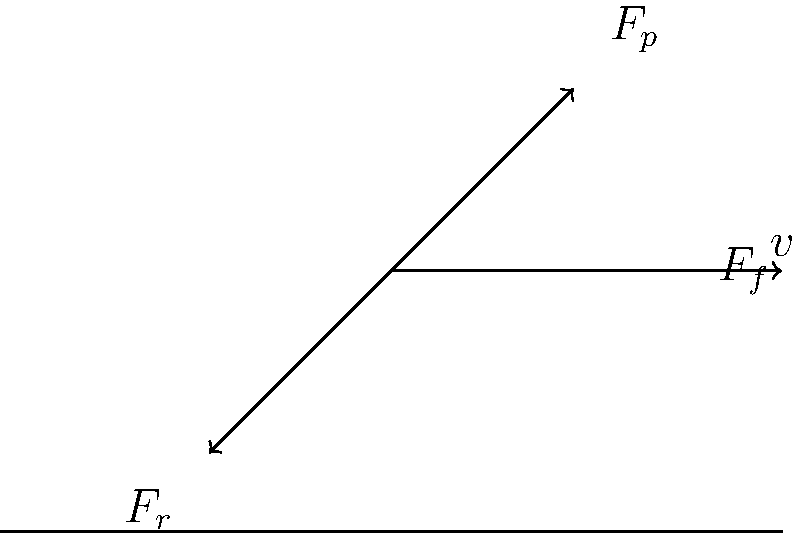While cycling through the bustling streets of Khulna, you apply a force $F_p$ on the pedal. If the wheel's radius is 0.3 m and you're maintaining a constant speed of 5 m/s, what is the magnitude of the resistive force $F_r$ acting on the wheel, assuming no energy loss in the system? To solve this problem, we'll follow these steps:

1) First, we need to understand that at constant speed, the net force on the system is zero. This means the propulsive force must equal the resistive force.

2) The propulsive force at the wheel rim ($F_f$) is related to the pedal force ($F_p$) through the gear ratio. However, we don't need to know this relationship for this problem.

3) The power input at the pedal equals the power output at the wheel rim (assuming no energy loss):

   $P_{in} = P_{out}$

4) Power is force times velocity. At the wheel rim:

   $P_{out} = F_f \cdot v$

5) This power must overcome the resistive force:

   $P_{out} = F_r \cdot v$

6) Therefore:

   $F_f \cdot v = F_r \cdot v$

7) The velocities cancel out, giving us:

   $F_f = F_r$

8) We don't know $F_f$, but we know it must equal $F_r$ for constant speed.

9) The rotational speed of the wheel $\omega$ (in rad/s) is related to the linear speed $v$ by:

   $v = \omega \cdot r$

   Where $r$ is the wheel radius.

10) Rearranging this:

    $\omega = \frac{v}{r} = \frac{5 \text{ m/s}}{0.3 \text{ m}} \approx 16.67 \text{ rad/s}$

11) However, we don't actually need this value for the final answer. The resistive force $F_r$ equals the propulsive force $F_f$, regardless of the wheel's rotational speed.

Therefore, without additional information about the pedal force or gear ratio, we cannot determine the exact magnitude of $F_r$.
Answer: Cannot be determined with given information 